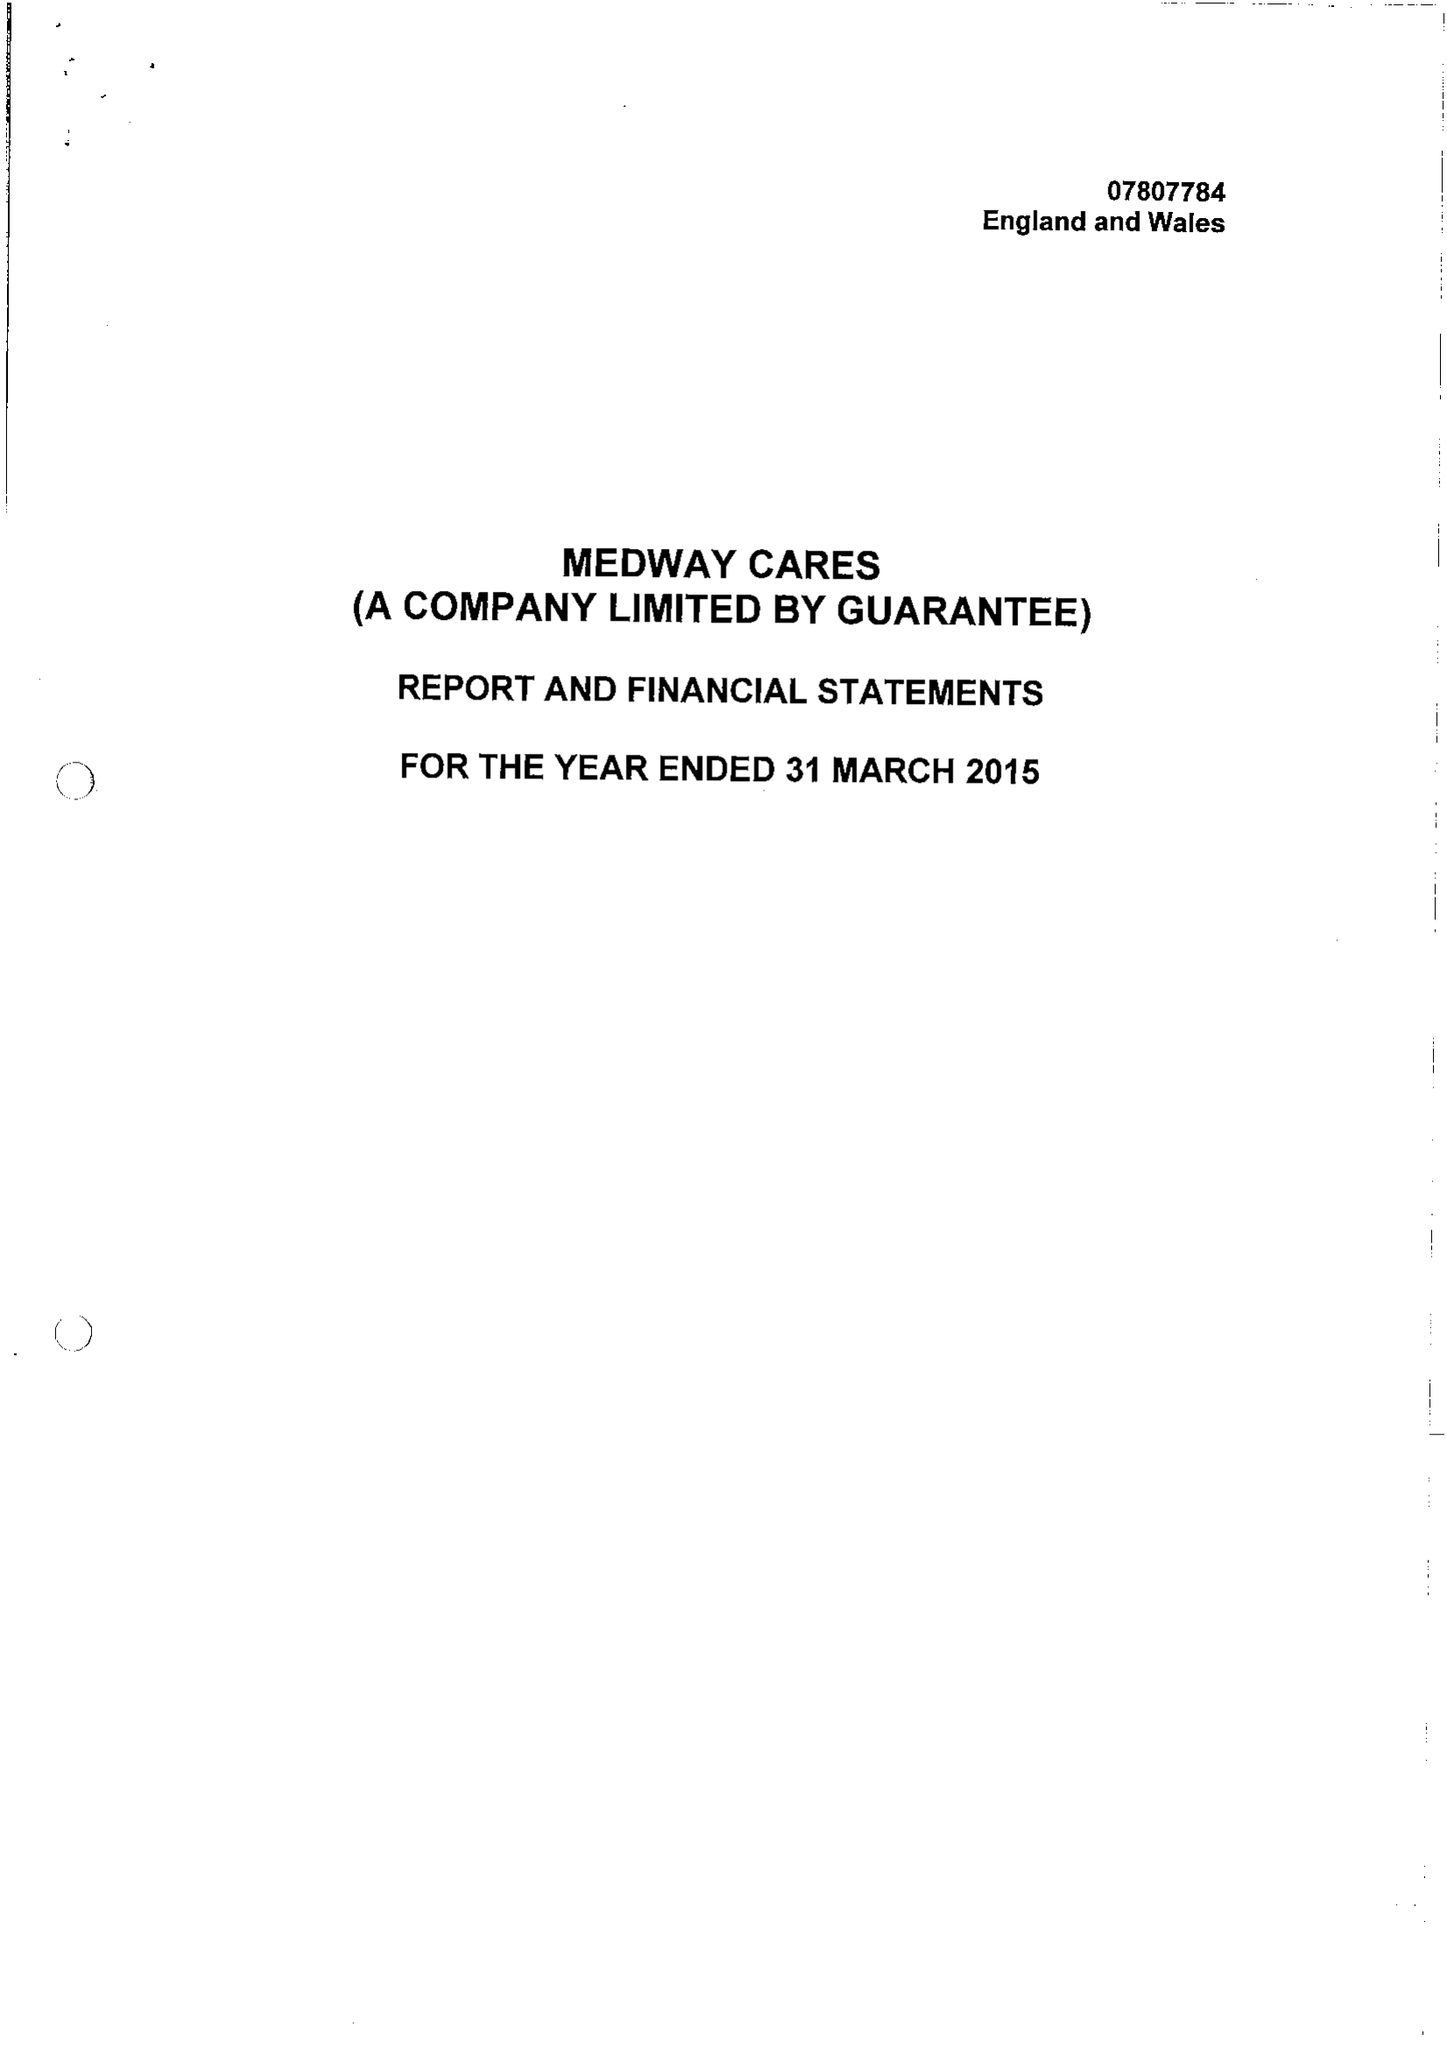What is the value for the report_date?
Answer the question using a single word or phrase. 2015-03-31 